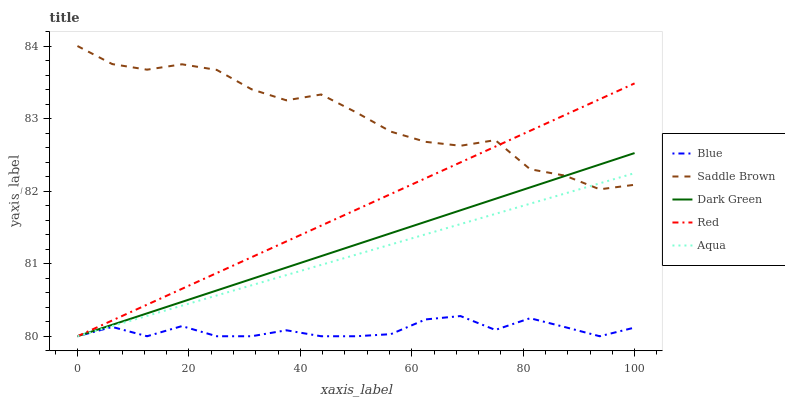Does Blue have the minimum area under the curve?
Answer yes or no. Yes. Does Saddle Brown have the maximum area under the curve?
Answer yes or no. Yes. Does Aqua have the minimum area under the curve?
Answer yes or no. No. Does Aqua have the maximum area under the curve?
Answer yes or no. No. Is Red the smoothest?
Answer yes or no. Yes. Is Saddle Brown the roughest?
Answer yes or no. Yes. Is Aqua the smoothest?
Answer yes or no. No. Is Aqua the roughest?
Answer yes or no. No. Does Blue have the lowest value?
Answer yes or no. Yes. Does Saddle Brown have the lowest value?
Answer yes or no. No. Does Saddle Brown have the highest value?
Answer yes or no. Yes. Does Aqua have the highest value?
Answer yes or no. No. Is Blue less than Saddle Brown?
Answer yes or no. Yes. Is Saddle Brown greater than Blue?
Answer yes or no. Yes. Does Red intersect Aqua?
Answer yes or no. Yes. Is Red less than Aqua?
Answer yes or no. No. Is Red greater than Aqua?
Answer yes or no. No. Does Blue intersect Saddle Brown?
Answer yes or no. No. 